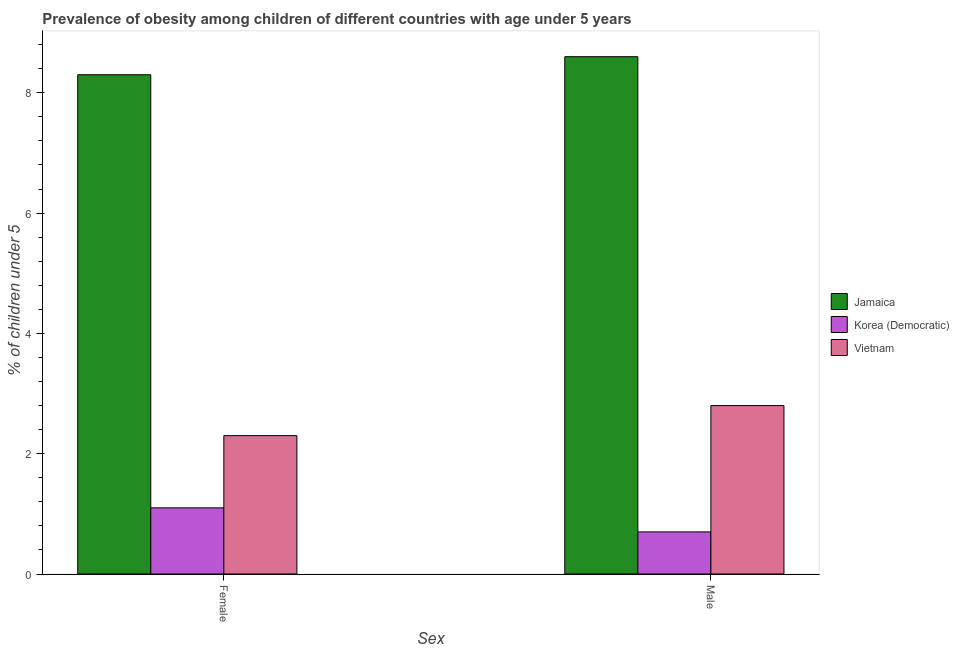How many bars are there on the 2nd tick from the right?
Give a very brief answer. 3. What is the label of the 2nd group of bars from the left?
Provide a short and direct response. Male. What is the percentage of obese male children in Vietnam?
Ensure brevity in your answer.  2.8. Across all countries, what is the maximum percentage of obese male children?
Provide a short and direct response. 8.6. Across all countries, what is the minimum percentage of obese female children?
Offer a very short reply. 1.1. In which country was the percentage of obese female children maximum?
Keep it short and to the point. Jamaica. In which country was the percentage of obese female children minimum?
Your answer should be compact. Korea (Democratic). What is the total percentage of obese male children in the graph?
Offer a terse response. 12.1. What is the difference between the percentage of obese male children in Jamaica and that in Korea (Democratic)?
Ensure brevity in your answer.  7.9. What is the difference between the percentage of obese male children in Korea (Democratic) and the percentage of obese female children in Vietnam?
Give a very brief answer. -1.6. What is the average percentage of obese male children per country?
Keep it short and to the point. 4.03. What is the difference between the percentage of obese female children and percentage of obese male children in Vietnam?
Make the answer very short. -0.5. In how many countries, is the percentage of obese male children greater than 6.8 %?
Provide a succinct answer. 1. What is the ratio of the percentage of obese female children in Jamaica to that in Korea (Democratic)?
Give a very brief answer. 7.55. What does the 2nd bar from the left in Female represents?
Your response must be concise. Korea (Democratic). What does the 1st bar from the right in Male represents?
Your answer should be compact. Vietnam. Are all the bars in the graph horizontal?
Your answer should be very brief. No. Does the graph contain grids?
Provide a succinct answer. No. Where does the legend appear in the graph?
Your answer should be compact. Center right. What is the title of the graph?
Offer a very short reply. Prevalence of obesity among children of different countries with age under 5 years. What is the label or title of the X-axis?
Ensure brevity in your answer.  Sex. What is the label or title of the Y-axis?
Give a very brief answer.  % of children under 5. What is the  % of children under 5 in Jamaica in Female?
Your answer should be compact. 8.3. What is the  % of children under 5 in Korea (Democratic) in Female?
Keep it short and to the point. 1.1. What is the  % of children under 5 in Vietnam in Female?
Offer a terse response. 2.3. What is the  % of children under 5 in Jamaica in Male?
Keep it short and to the point. 8.6. What is the  % of children under 5 of Korea (Democratic) in Male?
Provide a succinct answer. 0.7. What is the  % of children under 5 in Vietnam in Male?
Ensure brevity in your answer.  2.8. Across all Sex, what is the maximum  % of children under 5 in Jamaica?
Give a very brief answer. 8.6. Across all Sex, what is the maximum  % of children under 5 of Korea (Democratic)?
Provide a short and direct response. 1.1. Across all Sex, what is the maximum  % of children under 5 in Vietnam?
Your answer should be very brief. 2.8. Across all Sex, what is the minimum  % of children under 5 in Jamaica?
Provide a succinct answer. 8.3. Across all Sex, what is the minimum  % of children under 5 in Korea (Democratic)?
Ensure brevity in your answer.  0.7. Across all Sex, what is the minimum  % of children under 5 of Vietnam?
Your response must be concise. 2.3. What is the total  % of children under 5 in Korea (Democratic) in the graph?
Your answer should be very brief. 1.8. What is the total  % of children under 5 in Vietnam in the graph?
Your response must be concise. 5.1. What is the difference between the  % of children under 5 of Korea (Democratic) in Female and that in Male?
Keep it short and to the point. 0.4. What is the difference between the  % of children under 5 in Jamaica in Female and the  % of children under 5 in Vietnam in Male?
Give a very brief answer. 5.5. What is the average  % of children under 5 of Jamaica per Sex?
Provide a succinct answer. 8.45. What is the average  % of children under 5 in Korea (Democratic) per Sex?
Offer a very short reply. 0.9. What is the average  % of children under 5 in Vietnam per Sex?
Give a very brief answer. 2.55. What is the difference between the  % of children under 5 of Jamaica and  % of children under 5 of Korea (Democratic) in Female?
Provide a short and direct response. 7.2. What is the difference between the  % of children under 5 of Korea (Democratic) and  % of children under 5 of Vietnam in Female?
Your response must be concise. -1.2. What is the difference between the  % of children under 5 in Jamaica and  % of children under 5 in Korea (Democratic) in Male?
Offer a terse response. 7.9. What is the ratio of the  % of children under 5 of Jamaica in Female to that in Male?
Offer a very short reply. 0.97. What is the ratio of the  % of children under 5 in Korea (Democratic) in Female to that in Male?
Make the answer very short. 1.57. What is the ratio of the  % of children under 5 in Vietnam in Female to that in Male?
Ensure brevity in your answer.  0.82. What is the difference between the highest and the lowest  % of children under 5 in Korea (Democratic)?
Keep it short and to the point. 0.4. What is the difference between the highest and the lowest  % of children under 5 of Vietnam?
Keep it short and to the point. 0.5. 